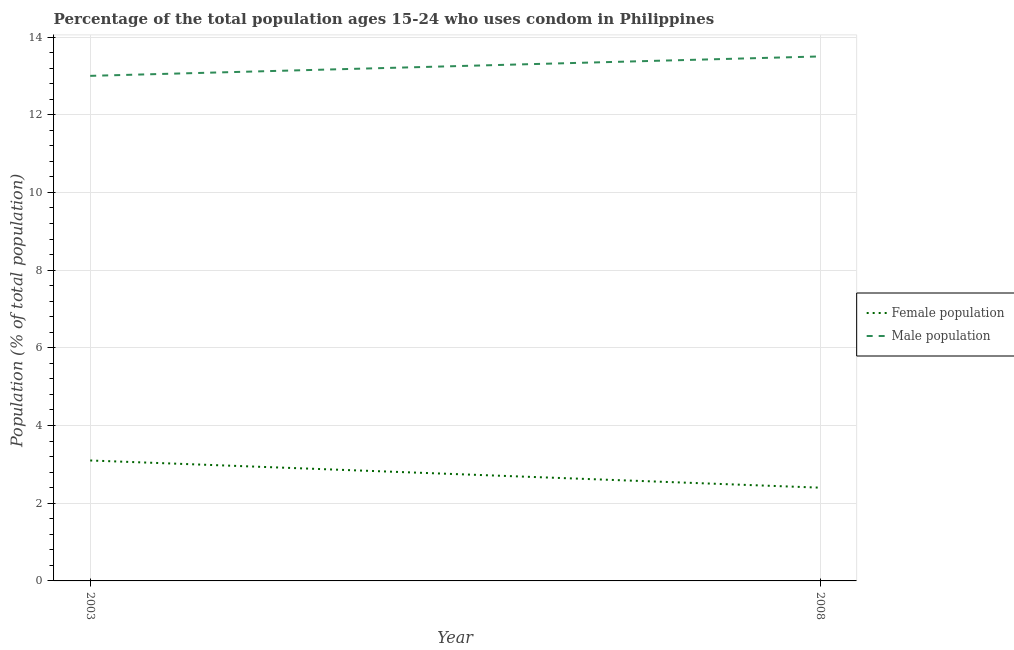How many different coloured lines are there?
Offer a terse response. 2. Does the line corresponding to male population intersect with the line corresponding to female population?
Your answer should be compact. No. Is the number of lines equal to the number of legend labels?
Offer a very short reply. Yes. Across all years, what is the minimum female population?
Your answer should be very brief. 2.4. In which year was the female population maximum?
Give a very brief answer. 2003. In which year was the male population minimum?
Ensure brevity in your answer.  2003. What is the difference between the female population in 2003 and that in 2008?
Keep it short and to the point. 0.7. What is the average male population per year?
Offer a very short reply. 13.25. In the year 2003, what is the difference between the male population and female population?
Give a very brief answer. 9.9. What is the ratio of the male population in 2003 to that in 2008?
Keep it short and to the point. 0.96. In how many years, is the female population greater than the average female population taken over all years?
Provide a short and direct response. 1. How many lines are there?
Provide a short and direct response. 2. What is the difference between two consecutive major ticks on the Y-axis?
Keep it short and to the point. 2. Are the values on the major ticks of Y-axis written in scientific E-notation?
Ensure brevity in your answer.  No. What is the title of the graph?
Provide a succinct answer. Percentage of the total population ages 15-24 who uses condom in Philippines. What is the label or title of the Y-axis?
Ensure brevity in your answer.  Population (% of total population) . What is the Population (% of total population)  in Male population in 2008?
Provide a succinct answer. 13.5. Across all years, what is the minimum Population (% of total population)  of Male population?
Make the answer very short. 13. What is the total Population (% of total population)  of Female population in the graph?
Your answer should be very brief. 5.5. What is the total Population (% of total population)  in Male population in the graph?
Provide a short and direct response. 26.5. What is the difference between the Population (% of total population)  in Female population in 2003 and that in 2008?
Your answer should be compact. 0.7. What is the difference between the Population (% of total population)  in Male population in 2003 and that in 2008?
Give a very brief answer. -0.5. What is the difference between the Population (% of total population)  of Female population in 2003 and the Population (% of total population)  of Male population in 2008?
Your answer should be compact. -10.4. What is the average Population (% of total population)  of Female population per year?
Your answer should be very brief. 2.75. What is the average Population (% of total population)  of Male population per year?
Your response must be concise. 13.25. In the year 2003, what is the difference between the Population (% of total population)  of Female population and Population (% of total population)  of Male population?
Provide a short and direct response. -9.9. In the year 2008, what is the difference between the Population (% of total population)  of Female population and Population (% of total population)  of Male population?
Your answer should be compact. -11.1. What is the ratio of the Population (% of total population)  in Female population in 2003 to that in 2008?
Make the answer very short. 1.29. What is the ratio of the Population (% of total population)  of Male population in 2003 to that in 2008?
Offer a terse response. 0.96. What is the difference between the highest and the second highest Population (% of total population)  of Female population?
Provide a short and direct response. 0.7. What is the difference between the highest and the lowest Population (% of total population)  in Female population?
Your answer should be very brief. 0.7. What is the difference between the highest and the lowest Population (% of total population)  in Male population?
Make the answer very short. 0.5. 